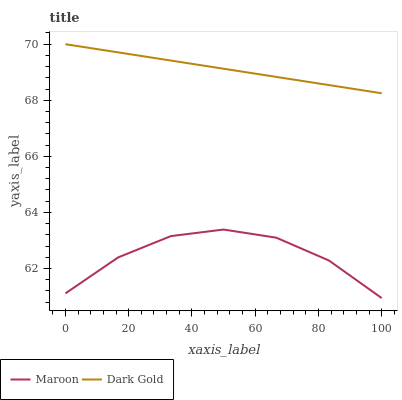Does Maroon have the minimum area under the curve?
Answer yes or no. Yes. Does Dark Gold have the maximum area under the curve?
Answer yes or no. Yes. Does Dark Gold have the minimum area under the curve?
Answer yes or no. No. Is Dark Gold the smoothest?
Answer yes or no. Yes. Is Maroon the roughest?
Answer yes or no. Yes. Is Dark Gold the roughest?
Answer yes or no. No. Does Dark Gold have the lowest value?
Answer yes or no. No. Does Dark Gold have the highest value?
Answer yes or no. Yes. Is Maroon less than Dark Gold?
Answer yes or no. Yes. Is Dark Gold greater than Maroon?
Answer yes or no. Yes. Does Maroon intersect Dark Gold?
Answer yes or no. No. 